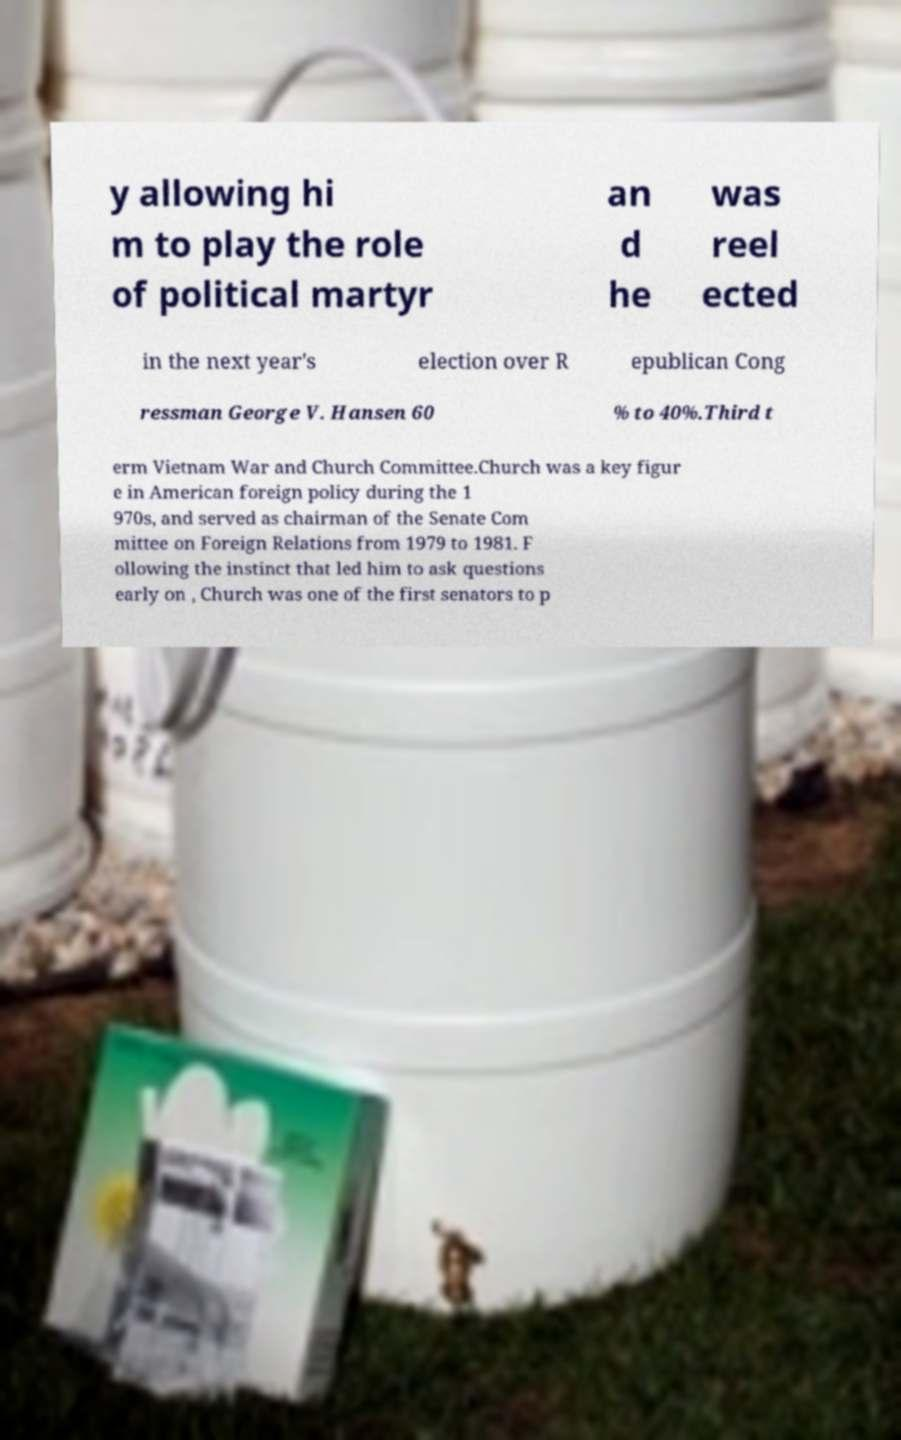Can you accurately transcribe the text from the provided image for me? y allowing hi m to play the role of political martyr an d he was reel ected in the next year's election over R epublican Cong ressman George V. Hansen 60 % to 40%.Third t erm Vietnam War and Church Committee.Church was a key figur e in American foreign policy during the 1 970s, and served as chairman of the Senate Com mittee on Foreign Relations from 1979 to 1981. F ollowing the instinct that led him to ask questions early on , Church was one of the first senators to p 